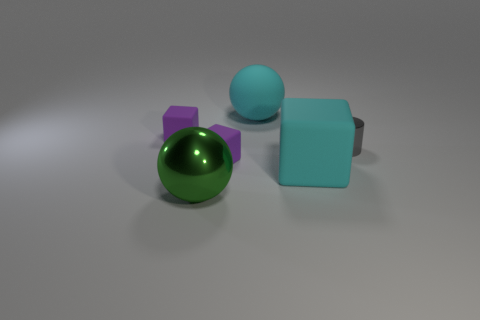There is a big object that is the same color as the rubber ball; what is its shape?
Your answer should be very brief. Cube. What is the material of the tiny purple object in front of the tiny gray object?
Your answer should be compact. Rubber. What number of small matte objects are the same shape as the gray shiny object?
Keep it short and to the point. 0. What shape is the other object that is the same material as the gray object?
Provide a short and direct response. Sphere. There is a big rubber object that is in front of the purple matte thing that is in front of the small matte block that is behind the gray cylinder; what shape is it?
Your answer should be very brief. Cube. Are there more tiny metallic cylinders than small cyan metallic cylinders?
Provide a succinct answer. Yes. What material is the cyan thing that is the same shape as the green object?
Your answer should be compact. Rubber. Does the large green ball have the same material as the gray cylinder?
Your response must be concise. Yes. Are there more purple blocks that are behind the tiny gray metal cylinder than tiny gray rubber cylinders?
Your answer should be very brief. Yes. There is a cyan object behind the small matte thing behind the purple cube that is right of the metallic ball; what is its material?
Your answer should be very brief. Rubber. 